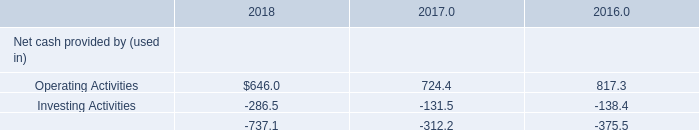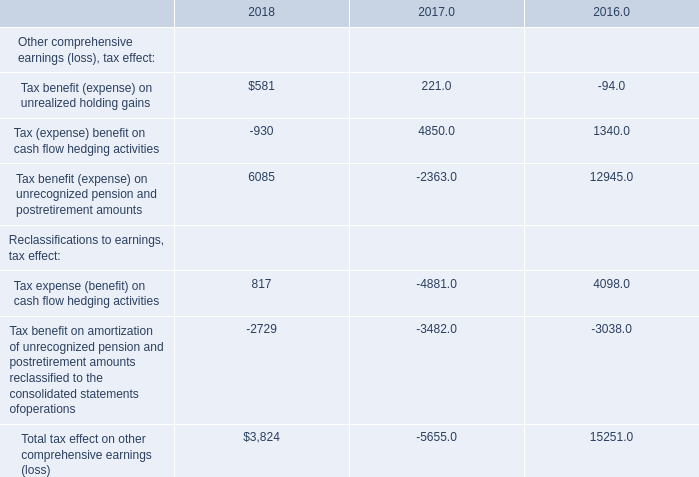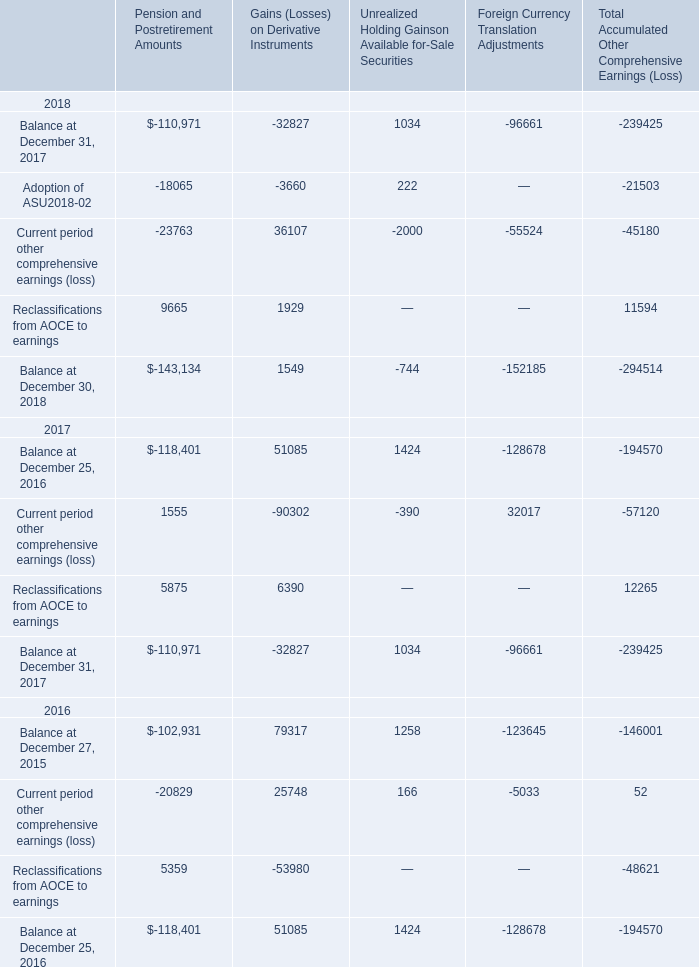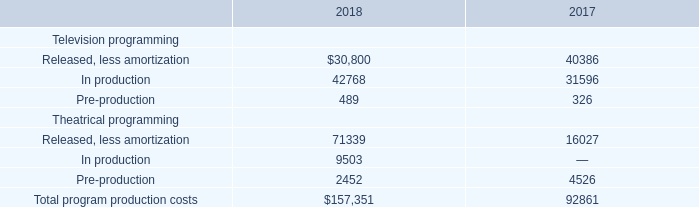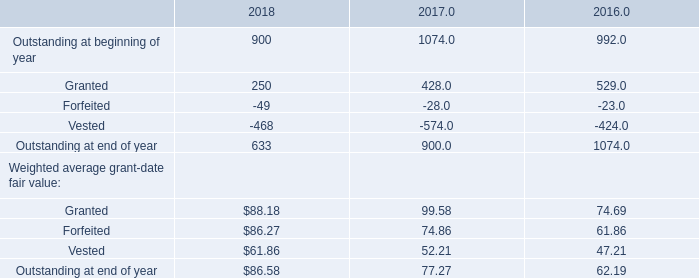What was the total amount of the Current period other comprehensive earnings (loss) in the years where Reclassifications from AOCE to earnings greater than 0? 
Computations: (-45180 - 57120)
Answer: -102300.0. 